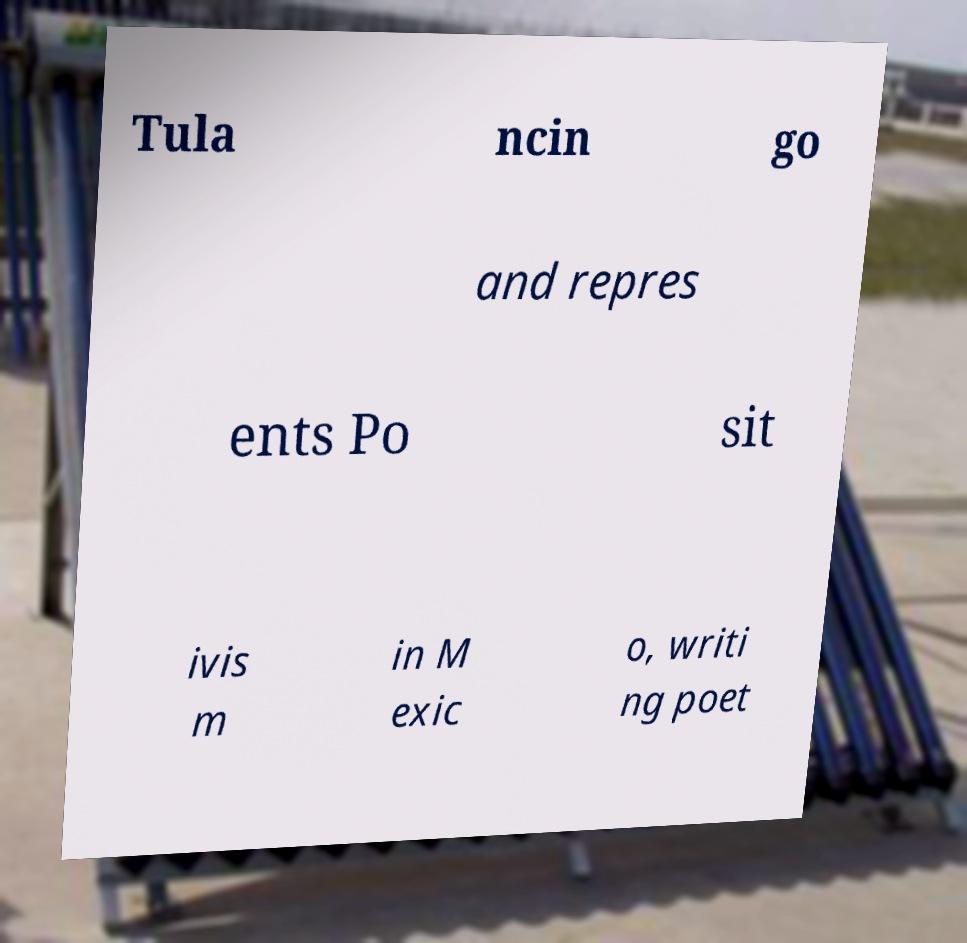Could you assist in decoding the text presented in this image and type it out clearly? Tula ncin go and repres ents Po sit ivis m in M exic o, writi ng poet 